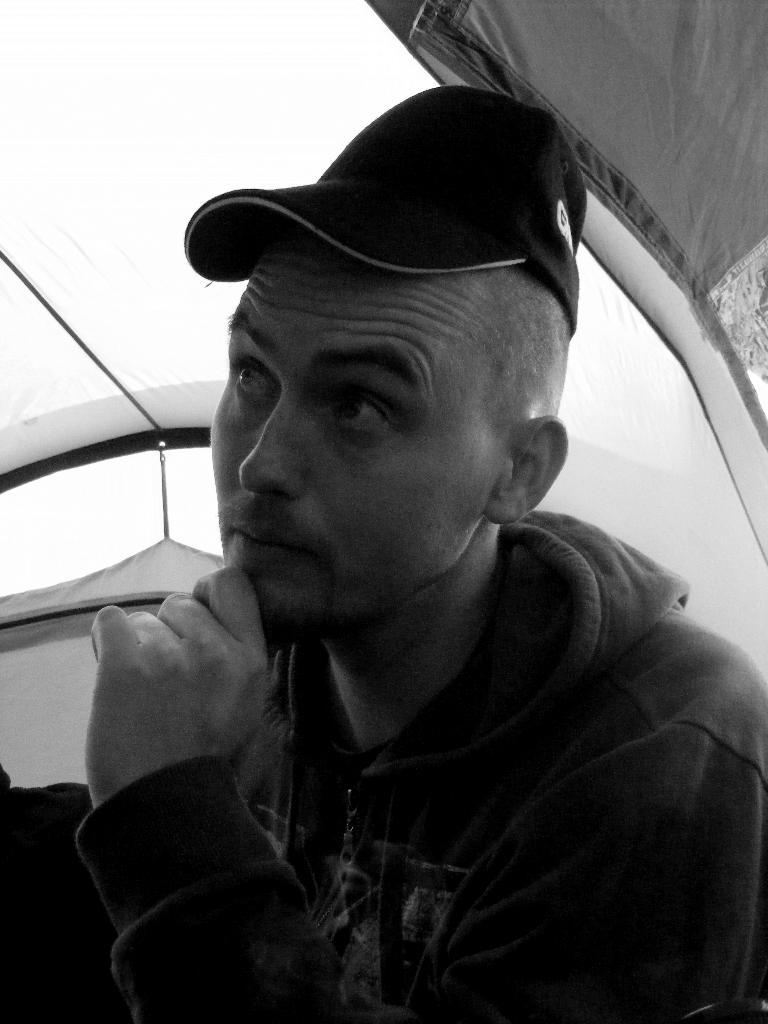What is the color scheme of the image? The image is black and white. Who is present in the image? There is a man in the image. What is the man wearing? The man is wearing a jacket and a cap. Which direction is the man looking? The man is looking to the left side. Where is the man located in the image? The man is under a tent. What type of silver object can be seen on the man's wrist in the image? There is no silver object visible on the man's wrist in the image. What error is the man making in the image? There is no error being made by the man in the image. 